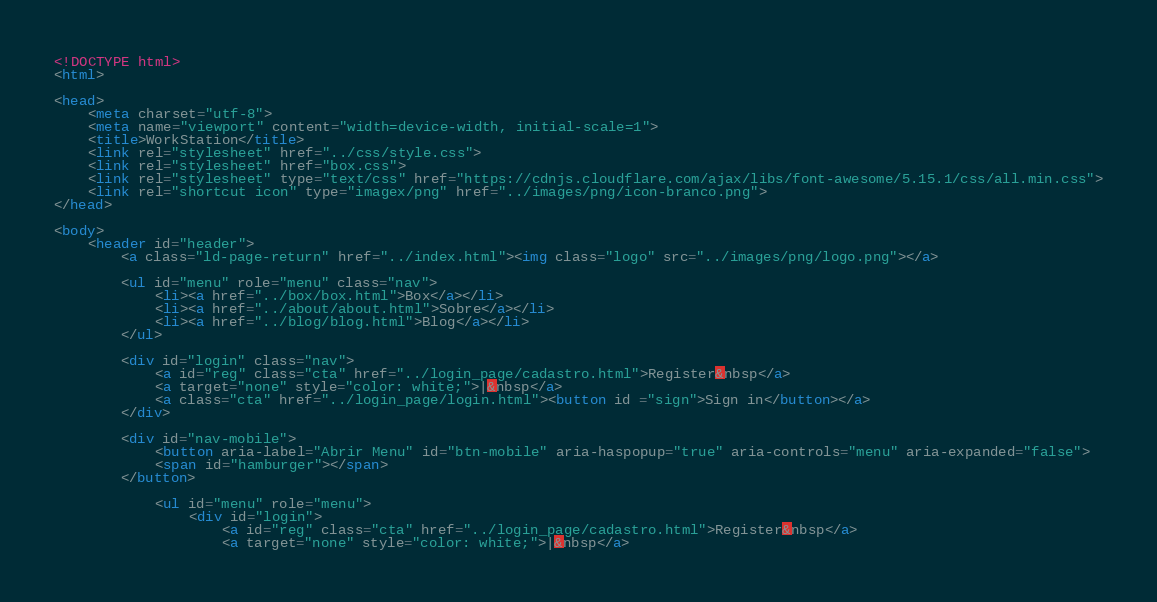<code> <loc_0><loc_0><loc_500><loc_500><_HTML_><!DOCTYPE html>
<html>

<head>
    <meta charset="utf-8">
    <meta name="viewport" content="width=device-width, initial-scale=1">
    <title>WorkStation</title>
    <link rel="stylesheet" href="../css/style.css">
    <link rel="stylesheet" href="box.css">
    <link rel="stylesheet" type="text/css" href="https://cdnjs.cloudflare.com/ajax/libs/font-awesome/5.15.1/css/all.min.css">
    <link rel="shortcut icon" type="imagex/png" href="../images/png/icon-branco.png">
</head>

<body>
    <header id="header">
        <a class="ld-page-return" href="../index.html"><img class="logo" src="../images/png/logo.png"></a>

        <ul id="menu" role="menu" class="nav">
            <li><a href="../box/box.html">Box</a></li>
            <li><a href="../about/about.html">Sobre</a></li>
            <li><a href="../blog/blog.html">Blog</a></li>
        </ul>

        <div id="login" class="nav">
            <a id="reg" class="cta" href="../login_page/cadastro.html">Register&nbsp</a>
            <a target="none" style="color: white;">|&nbsp</a>
            <a class="cta" href="../login_page/login.html"><button id ="sign">Sign in</button></a>
        </div>

        <div id="nav-mobile">
            <button aria-label="Abrir Menu" id="btn-mobile" aria-haspopup="true" aria-controls="menu" aria-expanded="false">
            <span id="hamburger"></span>
        </button>

            <ul id="menu" role="menu">
                <div id="login">
                    <a id="reg" class="cta" href="../login_page/cadastro.html">Register&nbsp</a>
                    <a target="none" style="color: white;">|&nbsp</a></code> 